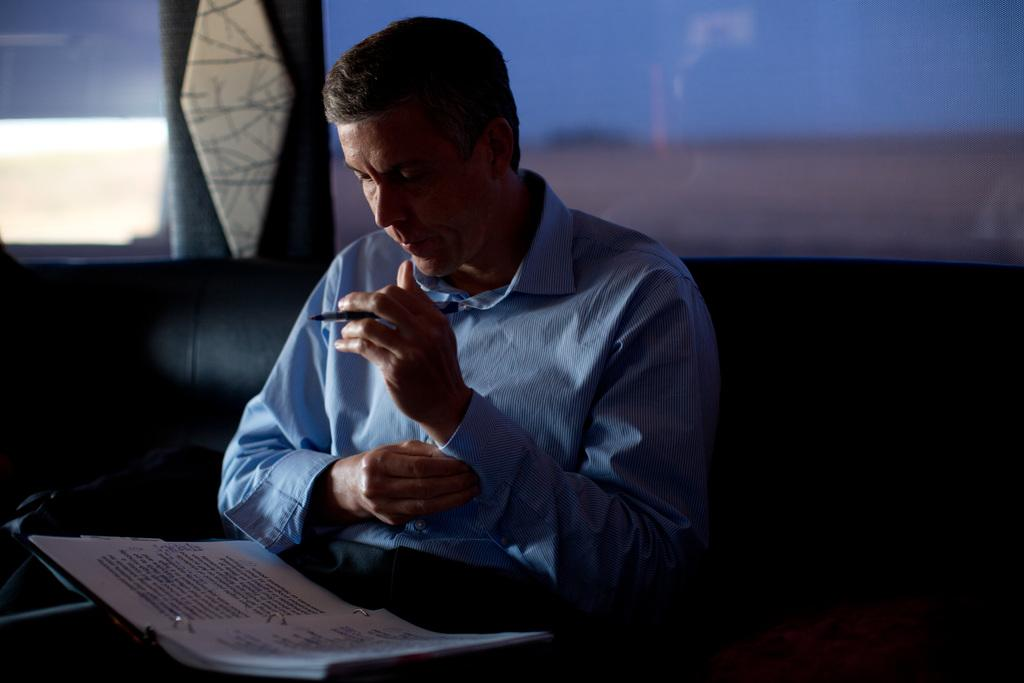What is the person in the image doing? The person is sitting on the couch and looking at a book. What is the person holding in the image? The person is holding a pen. How is the book positioned in relation to the person? The book is placed on the person's arms. What can be seen on the wall behind the person? There is a glass window on the wall behind the person. What type of patch is sewn onto the person's shirt in the image? There is no patch visible on the person's shirt in the image. How does the butter look on the person's finger in the image? There is no butter or finger present in the image. 